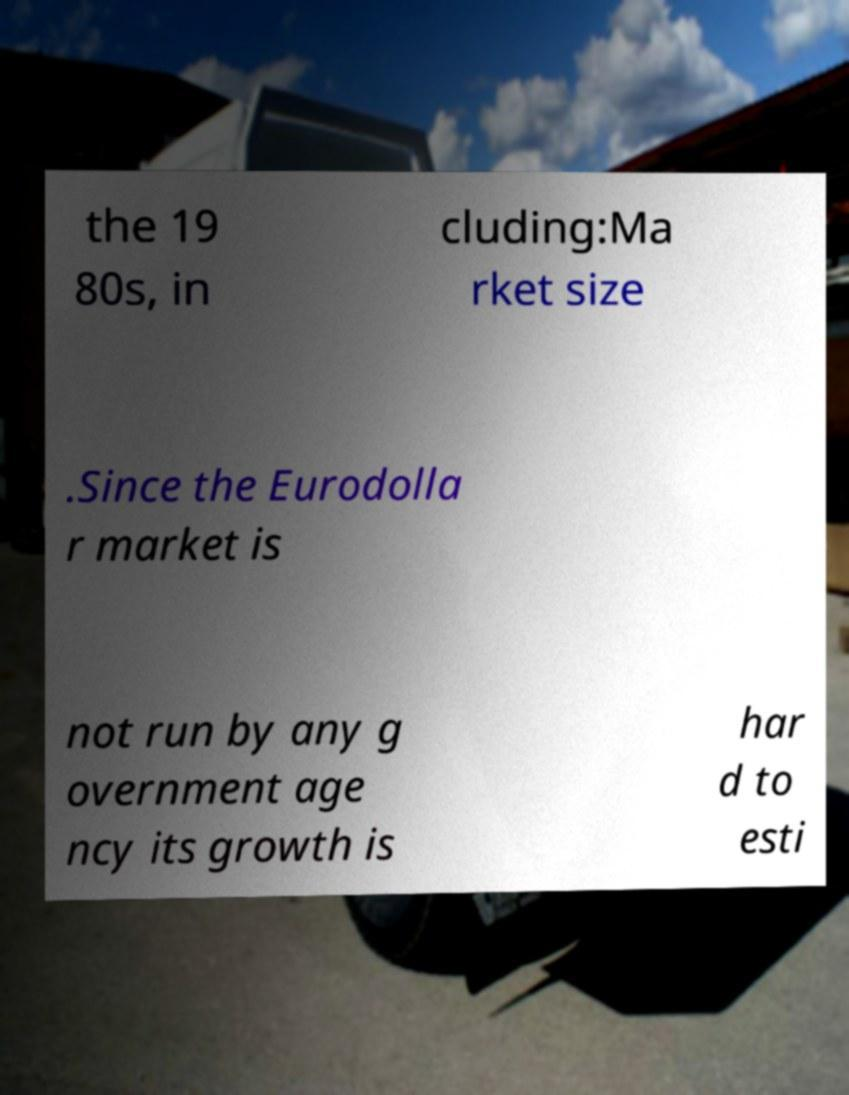Please read and relay the text visible in this image. What does it say? the 19 80s, in cluding:Ma rket size .Since the Eurodolla r market is not run by any g overnment age ncy its growth is har d to esti 